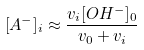<formula> <loc_0><loc_0><loc_500><loc_500>[ A ^ { - } ] _ { i } \approx \frac { v _ { i } [ O H ^ { - } ] _ { 0 } } { v _ { 0 } + v _ { i } }</formula> 